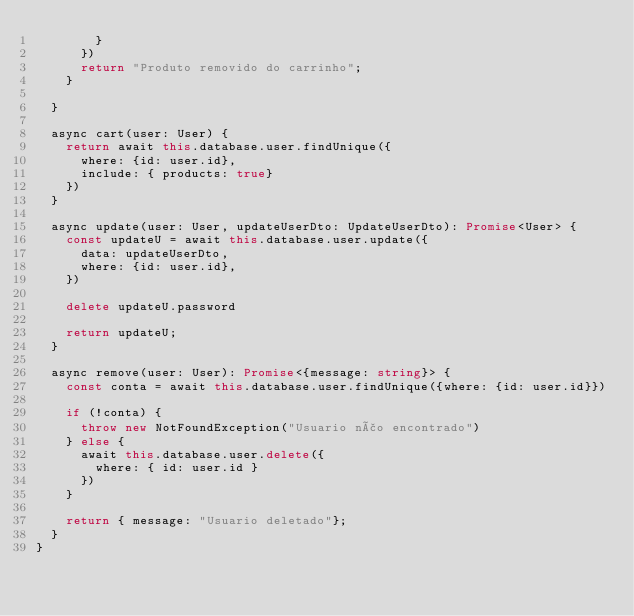Convert code to text. <code><loc_0><loc_0><loc_500><loc_500><_TypeScript_>        }
      })
      return "Produto removido do carrinho";
    }
    
  }

  async cart(user: User) {
    return await this.database.user.findUnique({
      where: {id: user.id},
      include: { products: true}
    })
  }

  async update(user: User, updateUserDto: UpdateUserDto): Promise<User> {
    const updateU = await this.database.user.update({
      data: updateUserDto,
      where: {id: user.id},
    })

    delete updateU.password

    return updateU;
  }

  async remove(user: User): Promise<{message: string}> {
    const conta = await this.database.user.findUnique({where: {id: user.id}})

    if (!conta) {
      throw new NotFoundException("Usuario não encontrado")
    } else {
      await this.database.user.delete({
        where: { id: user.id }
      })
    }

    return { message: "Usuario deletado"};
  }
}
</code> 